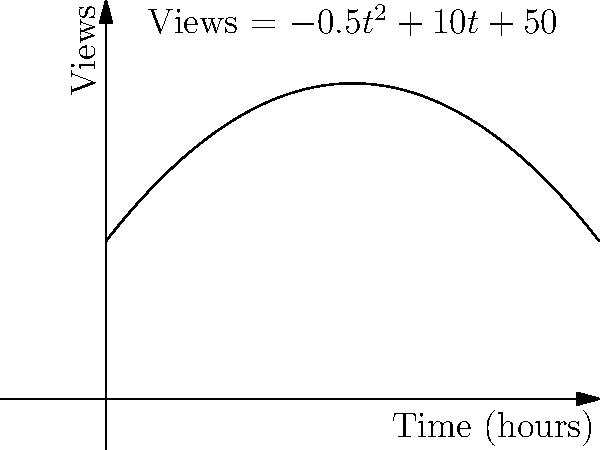As a news editor, you've noticed that the number of views for a breaking news article follows the quadratic function $V(t) = -0.5t^2 + 10t + 50$, where $V$ is the number of views (in thousands) and $t$ is the time in hours since publication. At what time does the article reach its peak number of views, and what is the maximum rate of change in views per hour? To solve this problem, we need to follow these steps:

1. Find the time of peak views:
   The function reaches its maximum when the derivative equals zero.
   $V'(t) = -t + 10$
   Set $V'(t) = 0$:
   $-t + 10 = 0$
   $t = 10$ hours

2. Calculate the maximum rate of change:
   The rate of change is given by the derivative $V'(t)$.
   The maximum rate occurs at $t = 0$ (when the article is first published).
   $V'(0) = -(0) + 10 = 10$ thousand views per hour

Therefore, the article reaches its peak number of views at 10 hours after publication, and the maximum rate of change is 10,000 views per hour, which occurs right at the beginning.
Answer: Peak time: 10 hours; Maximum rate: 10,000 views/hour 